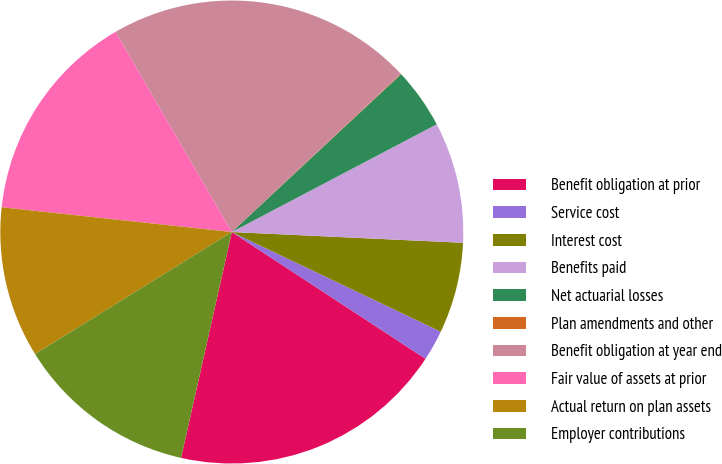<chart> <loc_0><loc_0><loc_500><loc_500><pie_chart><fcel>Benefit obligation at prior<fcel>Service cost<fcel>Interest cost<fcel>Benefits paid<fcel>Net actuarial losses<fcel>Plan amendments and other<fcel>Benefit obligation at year end<fcel>Fair value of assets at prior<fcel>Actual return on plan assets<fcel>Employer contributions<nl><fcel>19.29%<fcel>2.14%<fcel>6.34%<fcel>8.44%<fcel>4.24%<fcel>0.04%<fcel>21.39%<fcel>14.91%<fcel>10.54%<fcel>12.64%<nl></chart> 